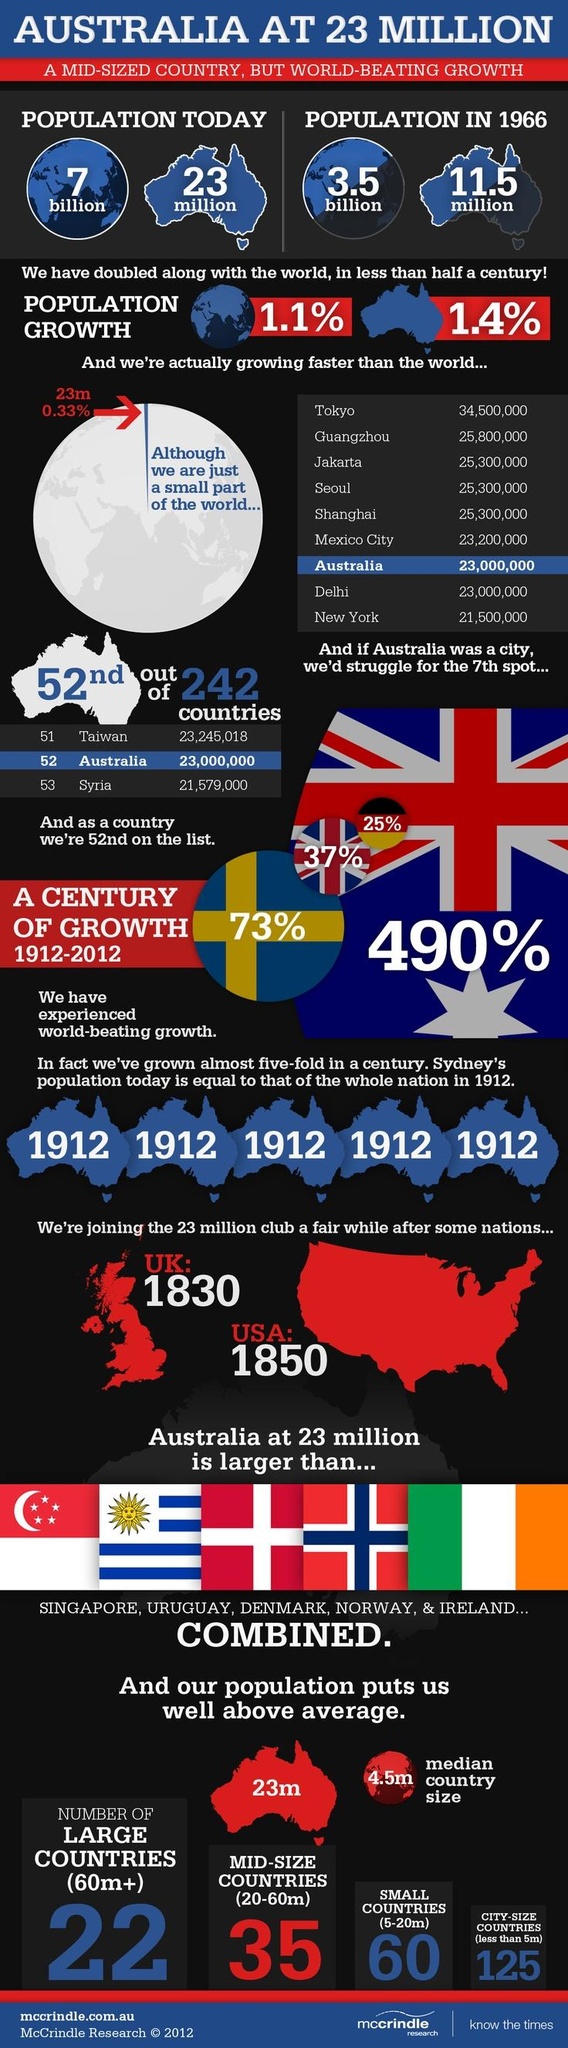Highlight a few significant elements in this photo. In 1966, the population of Australia was 11.5 million. There are approximately 60 small countries with populations ranging from 5 to 20 million. In 1966, the world's population was approximately 3.5 billion people. A total of 35 mid-sized countries with a population ranging from 20 to 60 million exist. 